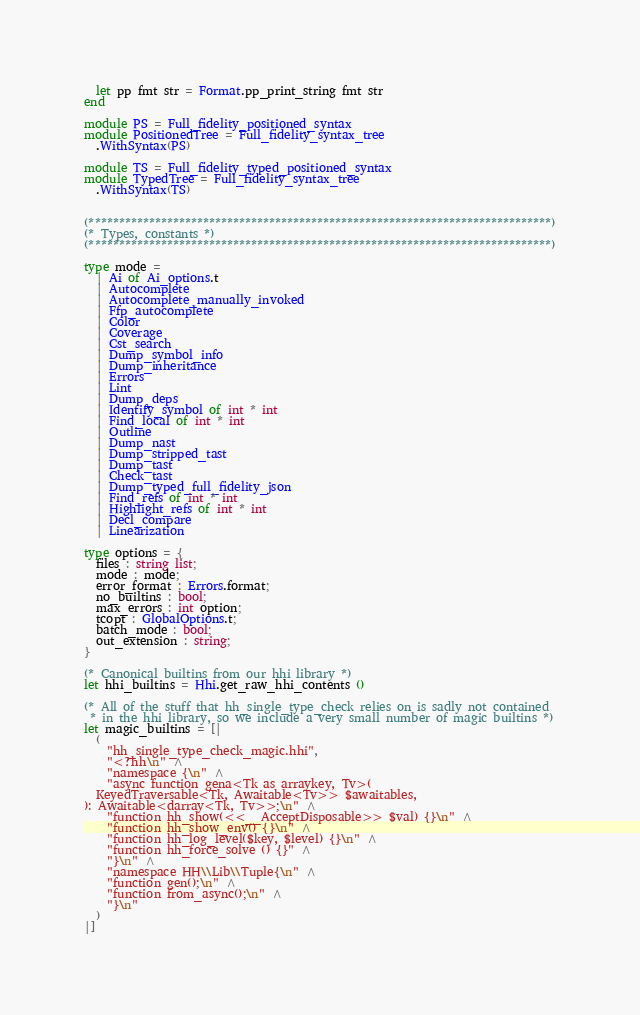Convert code to text. <code><loc_0><loc_0><loc_500><loc_500><_OCaml_>  let pp fmt str = Format.pp_print_string fmt str
end

module PS = Full_fidelity_positioned_syntax
module PositionedTree = Full_fidelity_syntax_tree
  .WithSyntax(PS)

module TS = Full_fidelity_typed_positioned_syntax
module TypedTree = Full_fidelity_syntax_tree
  .WithSyntax(TS)


(*****************************************************************************)
(* Types, constants *)
(*****************************************************************************)

type mode =
  | Ai of Ai_options.t
  | Autocomplete
  | Autocomplete_manually_invoked
  | Ffp_autocomplete
  | Color
  | Coverage
  | Cst_search
  | Dump_symbol_info
  | Dump_inheritance
  | Errors
  | Lint
  | Dump_deps
  | Identify_symbol of int * int
  | Find_local of int * int
  | Outline
  | Dump_nast
  | Dump_stripped_tast
  | Dump_tast
  | Check_tast
  | Dump_typed_full_fidelity_json
  | Find_refs of int * int
  | Highlight_refs of int * int
  | Decl_compare
  | Linearization

type options = {
  files : string list;
  mode : mode;
  error_format : Errors.format;
  no_builtins : bool;
  max_errors : int option;
  tcopt : GlobalOptions.t;
  batch_mode : bool;
  out_extension : string;
}

(* Canonical builtins from our hhi library *)
let hhi_builtins = Hhi.get_raw_hhi_contents ()

(* All of the stuff that hh_single_type_check relies on is sadly not contained
 * in the hhi library, so we include a very small number of magic builtins *)
let magic_builtins = [|
  (
    "hh_single_type_check_magic.hhi",
    "<?hh\n" ^
    "namespace {\n" ^
    "async function gena<Tk as arraykey, Tv>(
  KeyedTraversable<Tk, Awaitable<Tv>> $awaitables,
): Awaitable<darray<Tk, Tv>>;\n" ^
    "function hh_show(<<__AcceptDisposable>> $val) {}\n" ^
    "function hh_show_env() {}\n" ^
    "function hh_log_level($key, $level) {}\n" ^
    "function hh_force_solve () {}" ^
    "}\n" ^
    "namespace HH\\Lib\\Tuple{\n" ^
    "function gen();\n" ^
    "function from_async();\n" ^
    "}\n"
  )
|]
</code> 